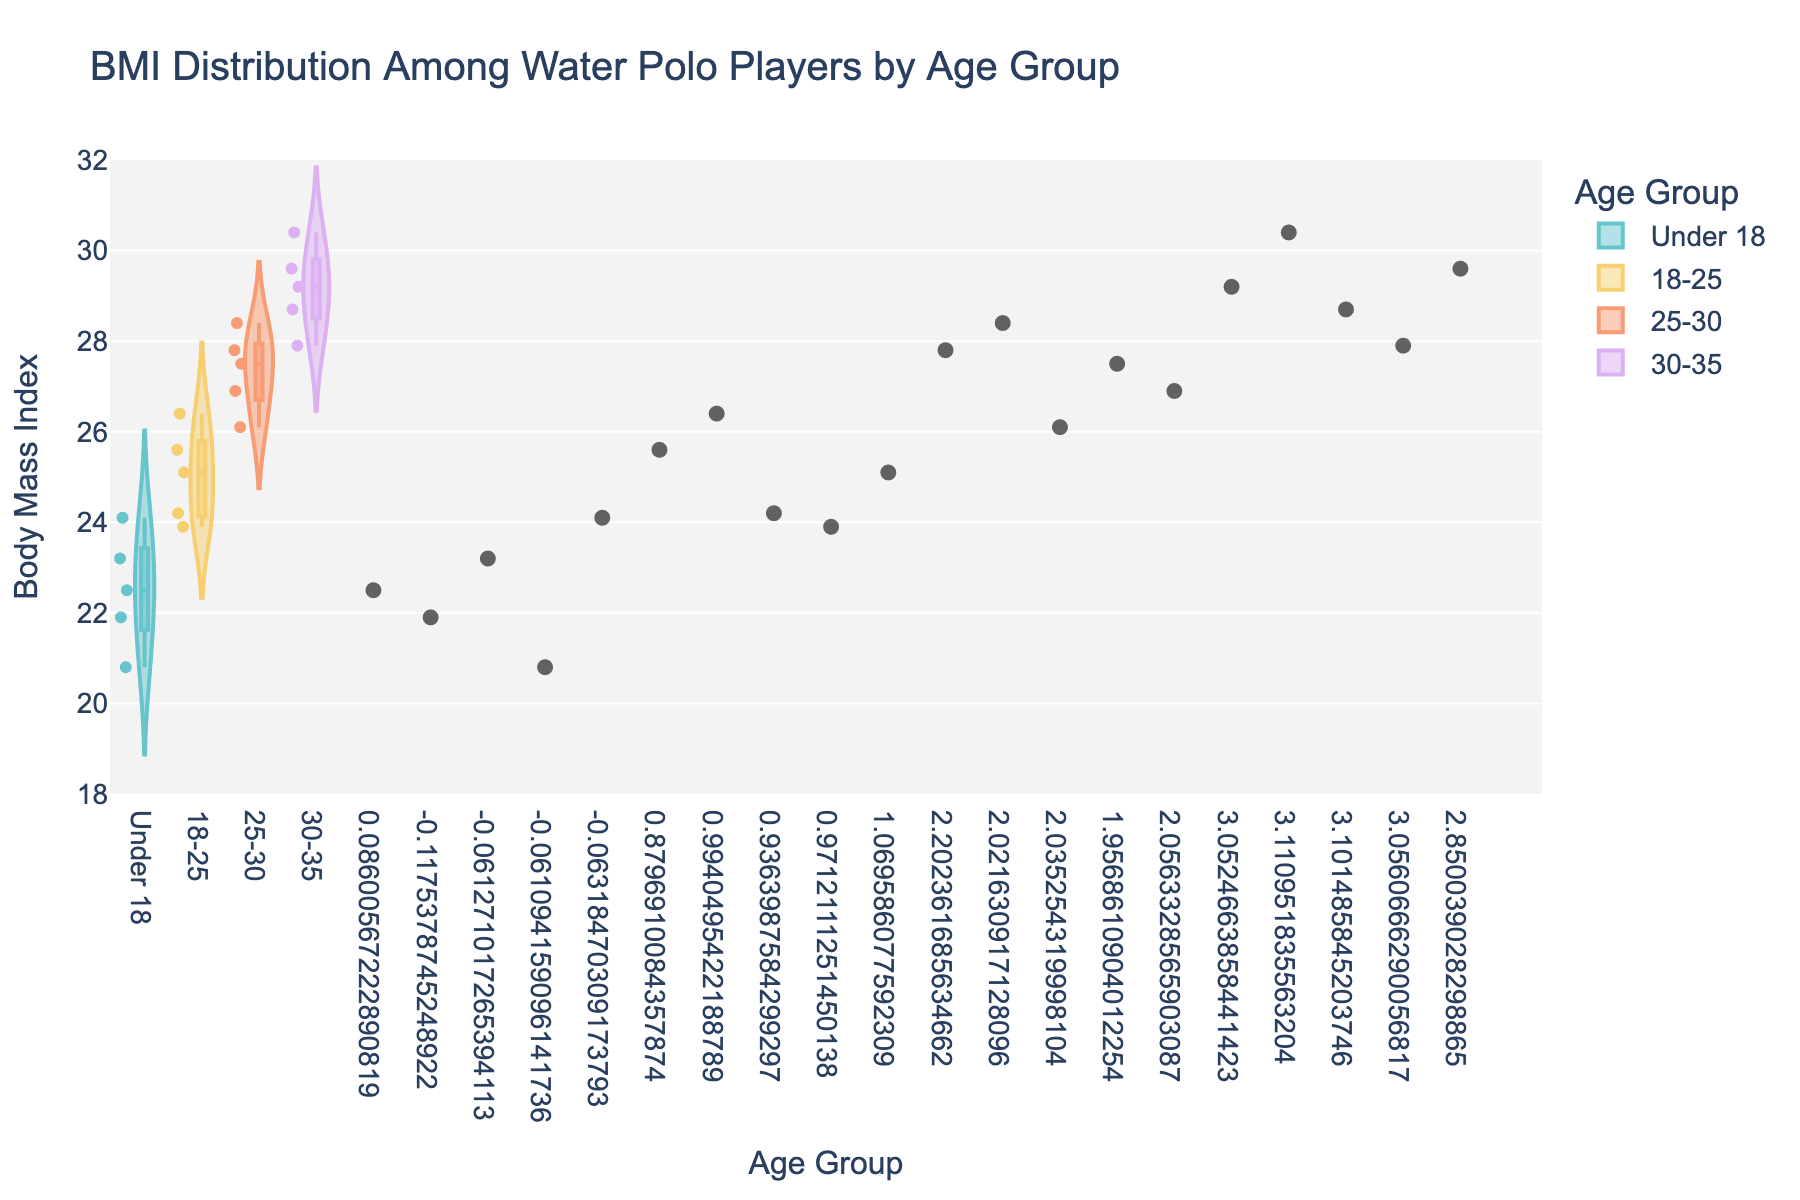what is the title of the figure? The title of the figure is displayed at the top of the chart and provides a summary of what the chart is about.
Answer: BMI Distribution Among Water Polo Players by Age Group What is the range of the y-axis? The range of the y-axis can be observed by looking at the numerical scale on the left side of the chart. The minimum value is 18 and the maximum value is 32.
Answer: 18 to 32 Which age group has the highest median BMI? To find the highest median BMI, observe the central white line inside each violin shape representing the median for each age group.
Answer: 30-35 How many data points are there for the 25-30 age group? Count the jittered points that are scattered within the 25-30 age group section of the chart.
Answer: 5 Which age group shows the widest range of BMI values? To determine the widest range, compare the vertical spread of each violin plot. The group with the largest vertical spread has the widest range.
Answer: 25-30 What is the approximate median BMI value for the Under 18 age group? Locate the central white line (representing the median) within the Under 18 violin plot and read its value from the y-axis.
Answer: 22.5 Compare the BMI distributions of the 18-25 and 25-30 age groups. Which group appears to have a more consistent BMI? To assess consistency, observe the spread of the violin plots. The group with a narrower violin plot has a more consistent distribution.
Answer: 18-25 What is the average BMI value for the 30-35 age group? Sum the BMI values for the 30-35 age group and divide by the number of data points. The BMI values are 29.2, 30.4, 28.7, 27.9, 29.6. The average is (29.2 + 30.4 + 28.7 + 27.9 + 29.6)/5 = 29.16.
Answer: 29.16 